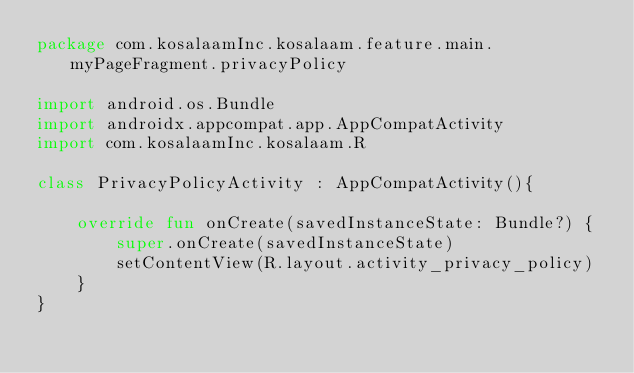Convert code to text. <code><loc_0><loc_0><loc_500><loc_500><_Kotlin_>package com.kosalaamInc.kosalaam.feature.main.myPageFragment.privacyPolicy

import android.os.Bundle
import androidx.appcompat.app.AppCompatActivity
import com.kosalaamInc.kosalaam.R

class PrivacyPolicyActivity : AppCompatActivity(){

    override fun onCreate(savedInstanceState: Bundle?) {
        super.onCreate(savedInstanceState)
        setContentView(R.layout.activity_privacy_policy)
    }
}</code> 